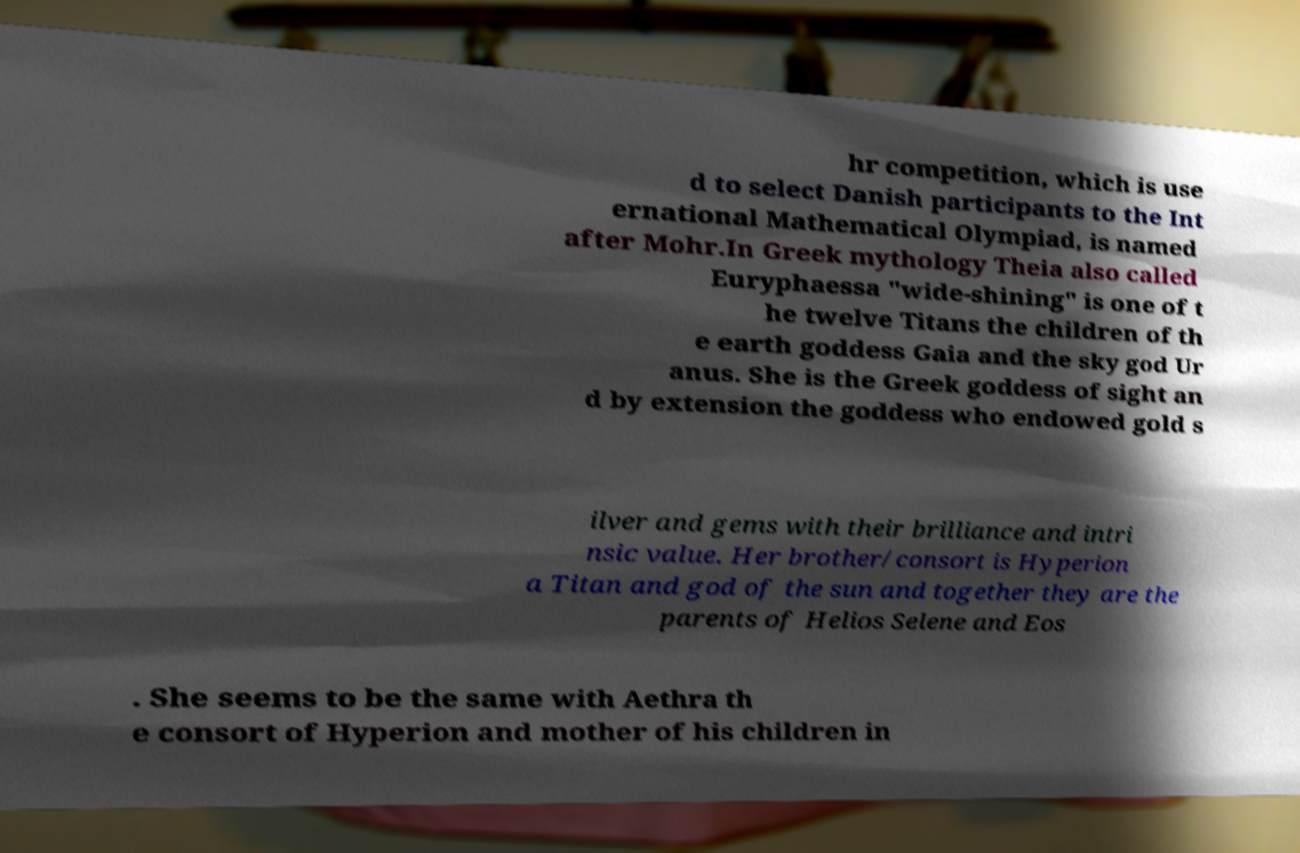Please identify and transcribe the text found in this image. hr competition, which is use d to select Danish participants to the Int ernational Mathematical Olympiad, is named after Mohr.In Greek mythology Theia also called Euryphaessa "wide-shining" is one of t he twelve Titans the children of th e earth goddess Gaia and the sky god Ur anus. She is the Greek goddess of sight an d by extension the goddess who endowed gold s ilver and gems with their brilliance and intri nsic value. Her brother/consort is Hyperion a Titan and god of the sun and together they are the parents of Helios Selene and Eos . She seems to be the same with Aethra th e consort of Hyperion and mother of his children in 